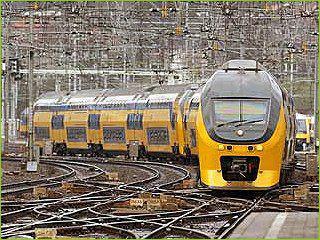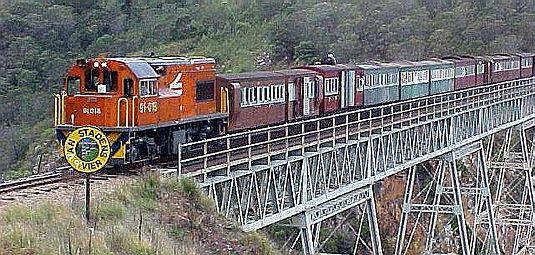The first image is the image on the left, the second image is the image on the right. Evaluate the accuracy of this statement regarding the images: "The front car of the train in the right image has a red tint to it.". Is it true? Answer yes or no. Yes. The first image is the image on the left, the second image is the image on the right. Examine the images to the left and right. Is the description "there are two sets of trains in the right side image" accurate? Answer yes or no. No. 